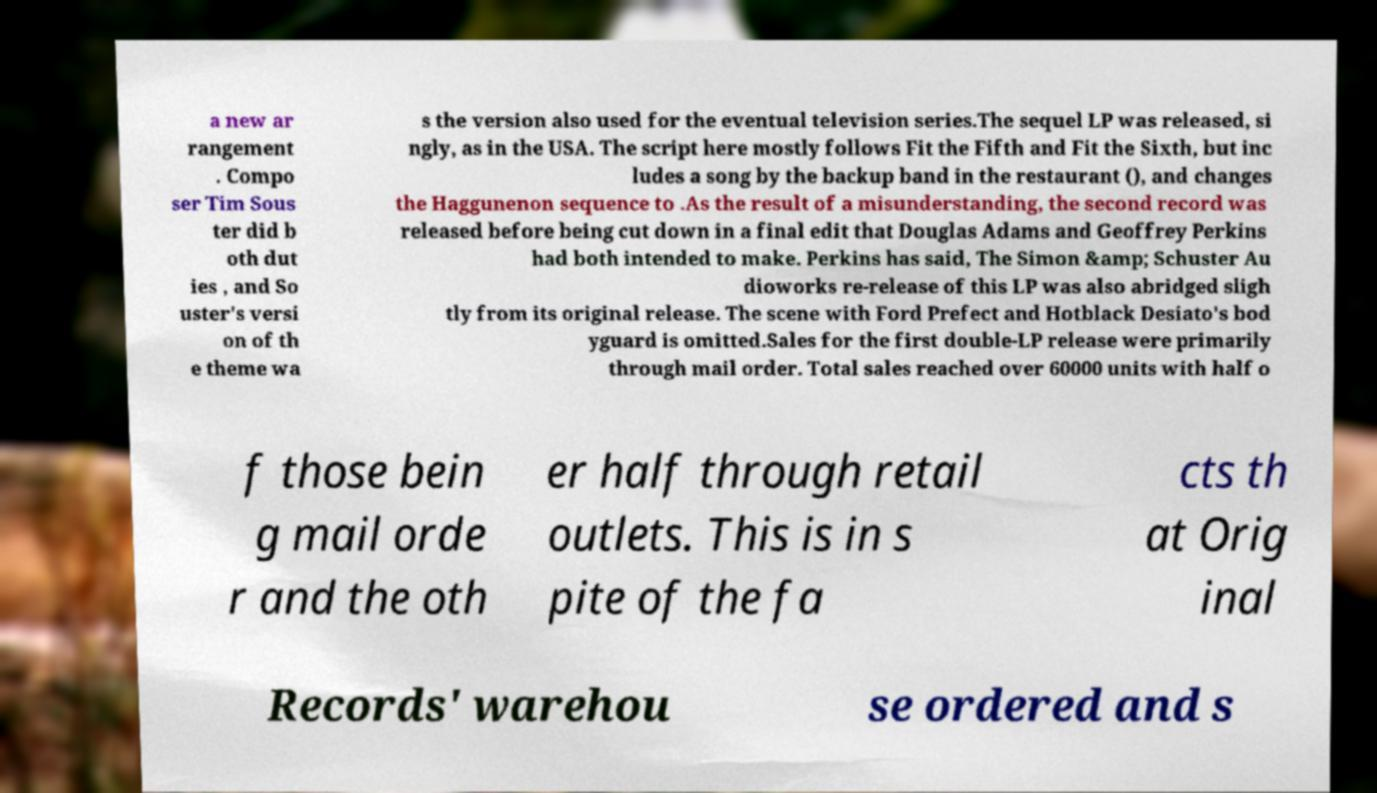Could you assist in decoding the text presented in this image and type it out clearly? a new ar rangement . Compo ser Tim Sous ter did b oth dut ies , and So uster's versi on of th e theme wa s the version also used for the eventual television series.The sequel LP was released, si ngly, as in the USA. The script here mostly follows Fit the Fifth and Fit the Sixth, but inc ludes a song by the backup band in the restaurant (), and changes the Haggunenon sequence to .As the result of a misunderstanding, the second record was released before being cut down in a final edit that Douglas Adams and Geoffrey Perkins had both intended to make. Perkins has said, The Simon &amp; Schuster Au dioworks re-release of this LP was also abridged sligh tly from its original release. The scene with Ford Prefect and Hotblack Desiato's bod yguard is omitted.Sales for the first double-LP release were primarily through mail order. Total sales reached over 60000 units with half o f those bein g mail orde r and the oth er half through retail outlets. This is in s pite of the fa cts th at Orig inal Records' warehou se ordered and s 